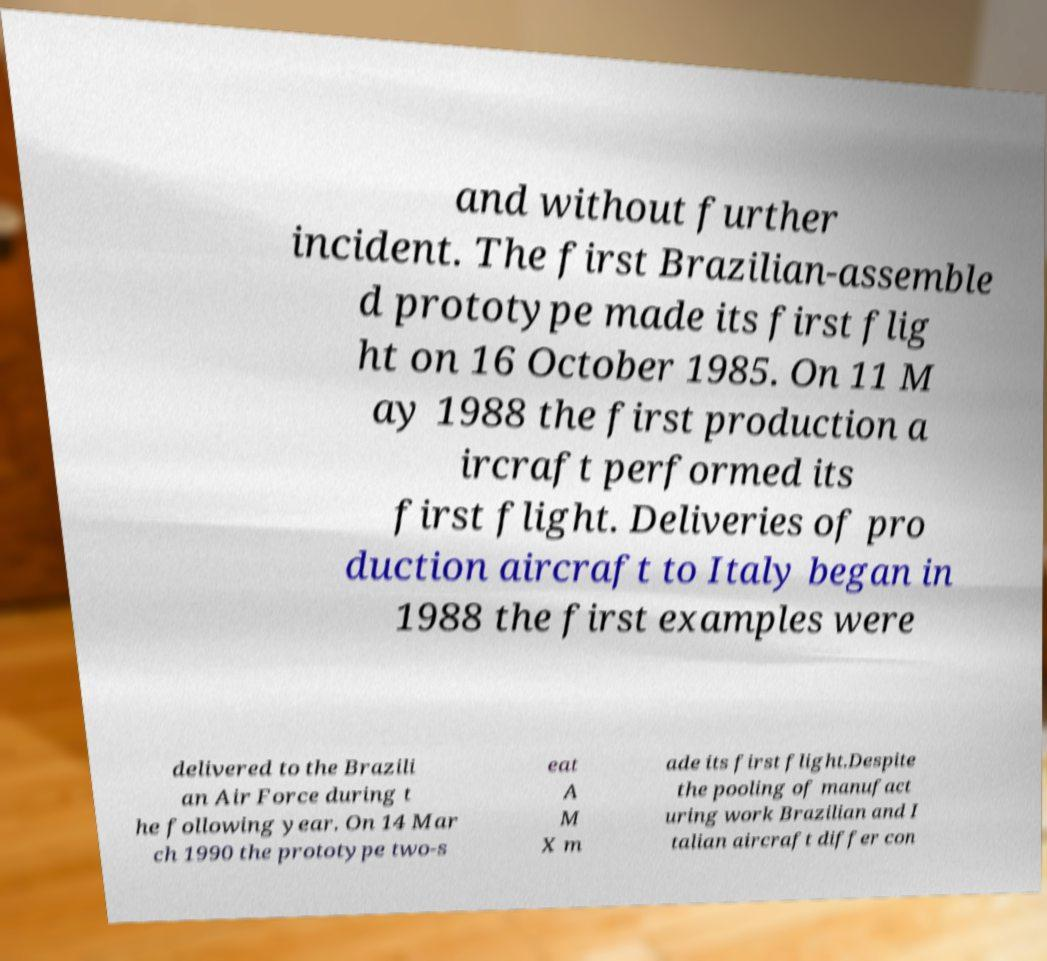Could you extract and type out the text from this image? and without further incident. The first Brazilian-assemble d prototype made its first flig ht on 16 October 1985. On 11 M ay 1988 the first production a ircraft performed its first flight. Deliveries of pro duction aircraft to Italy began in 1988 the first examples were delivered to the Brazili an Air Force during t he following year. On 14 Mar ch 1990 the prototype two-s eat A M X m ade its first flight.Despite the pooling of manufact uring work Brazilian and I talian aircraft differ con 